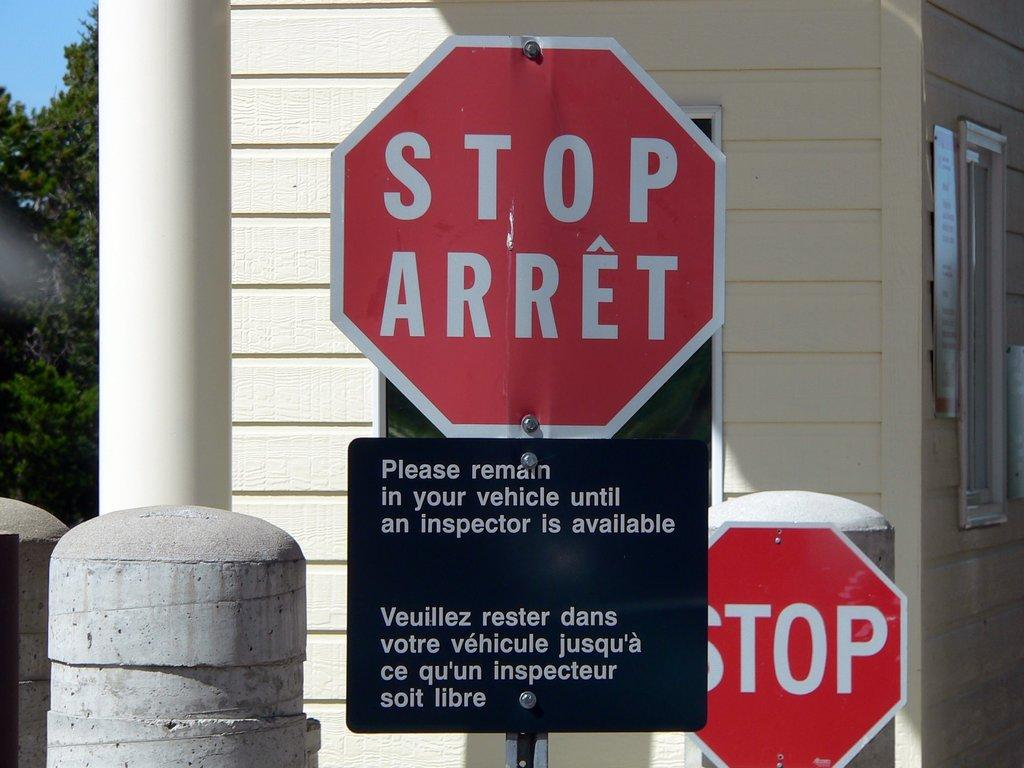<image>
Describe the image concisely. A red sign says Stop Arret and a black sign beneath it says Please remain in your vehicle until an inspector is available. 